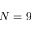Convert formula to latex. <formula><loc_0><loc_0><loc_500><loc_500>N = 9</formula> 